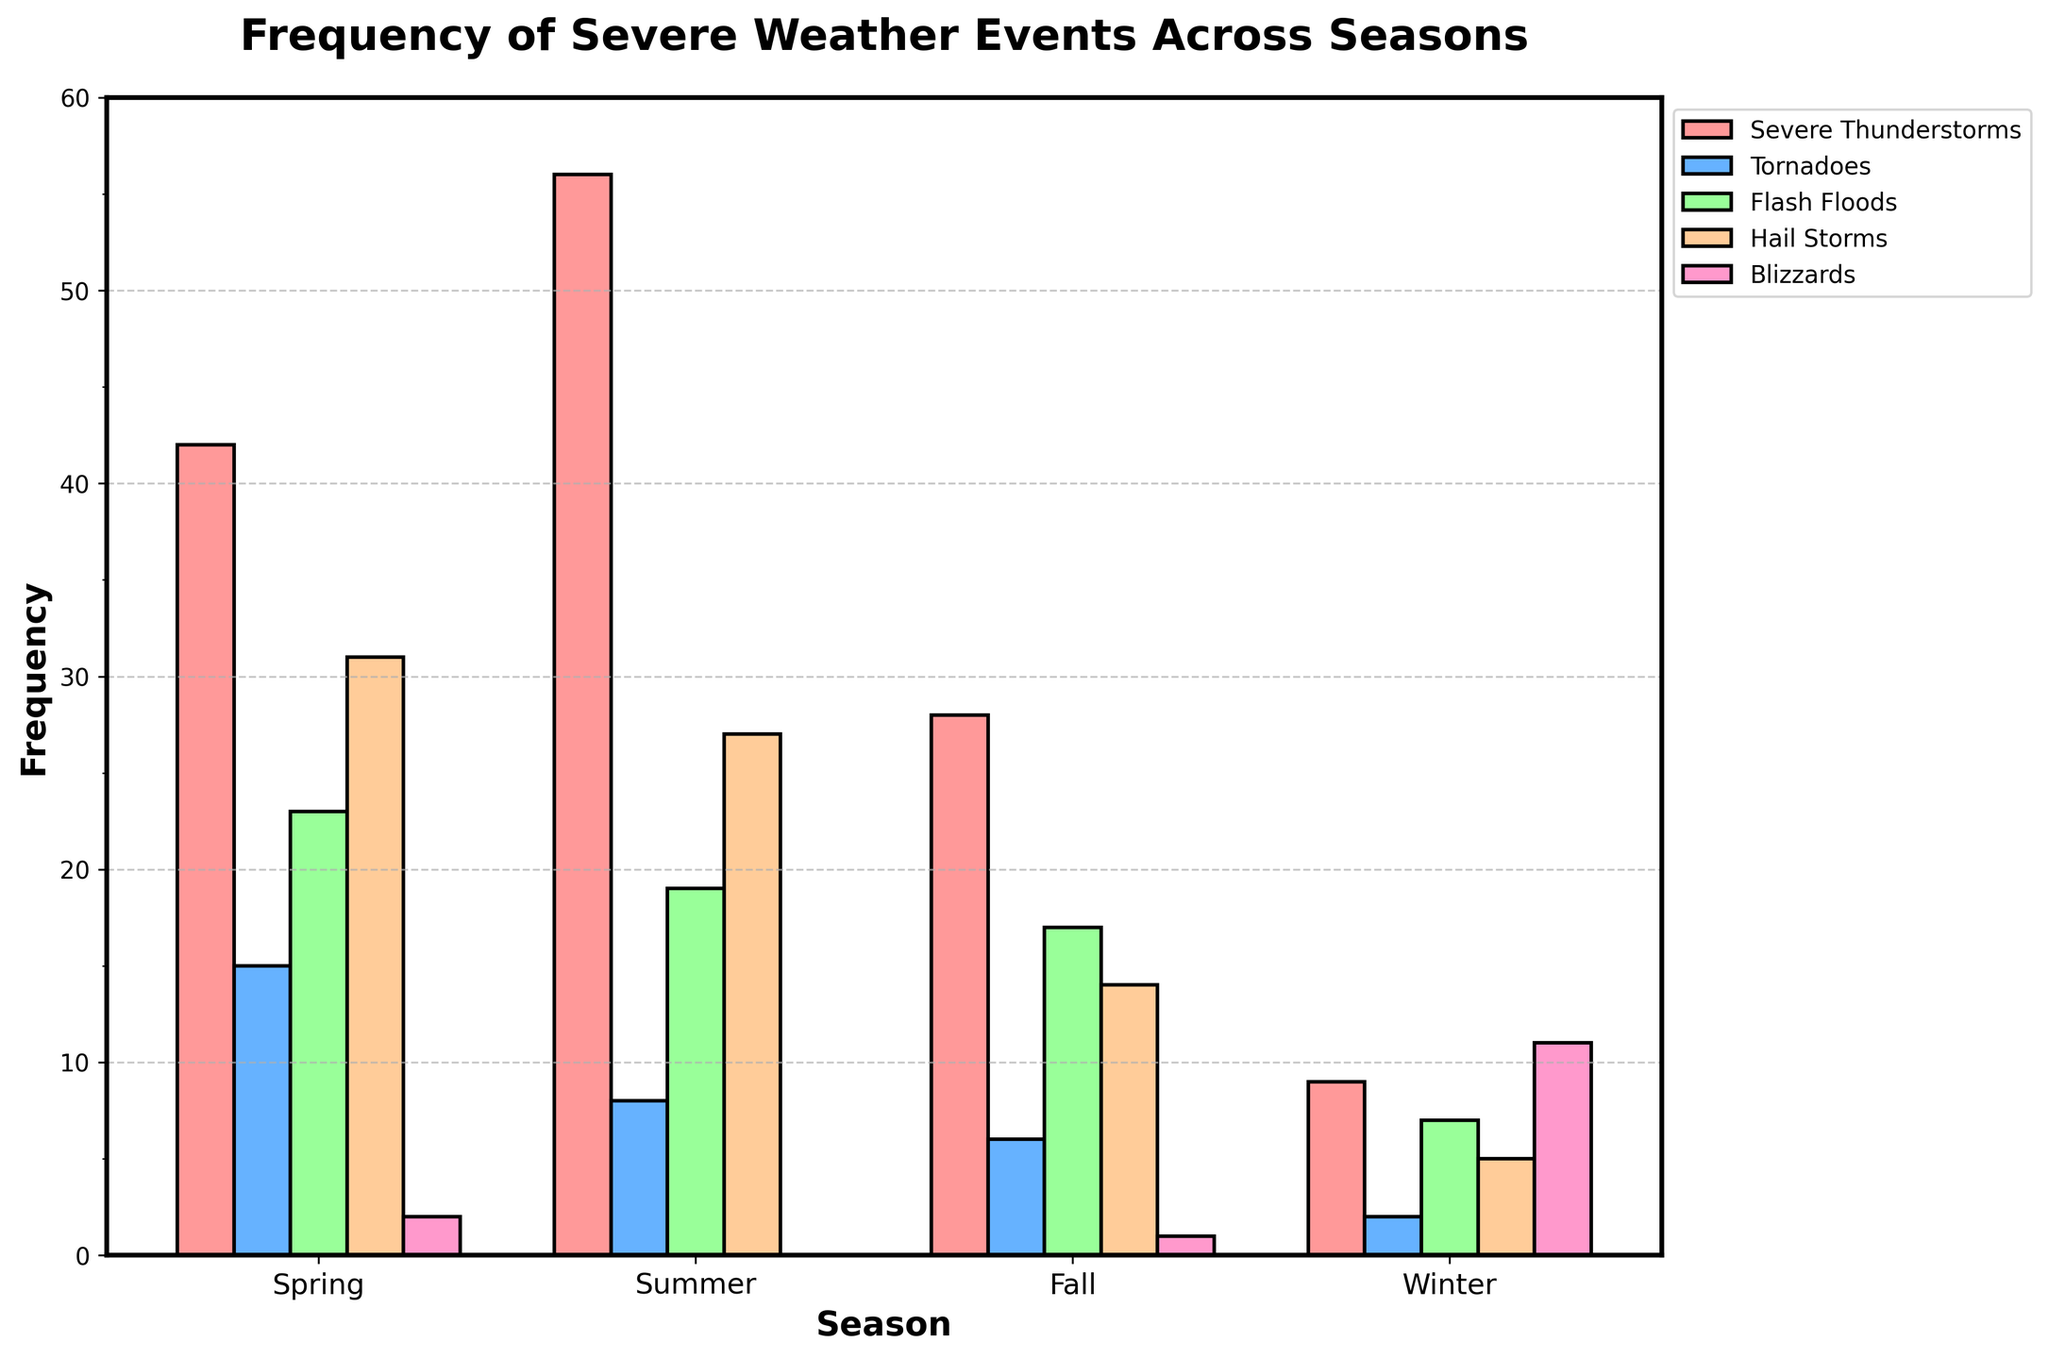Which season has the highest frequency of Severe Thunderstorms? Look at the bar heights in the Severe Thunderstorms category across all seasons and find the tallest one. Summer has the highest bar for Severe Thunderstorms.
Answer: Summer How many more Tornadoes occur in Spring compared to Fall? Find the heights of the Tornado bars for both Spring and Fall and subtract the two values. Spring has 15 Tornadoes, and Fall has 6, so 15 - 6 = 9.
Answer: 9 Which season has the lowest frequency of Flash Floods? Compare the heights of the Flash Flood bars for all seasons. Winter has the shortest bar for Flash Floods.
Answer: Winter What is the combined frequency of Hail Storms in Spring and Summer? Add the heights of the Hail Storm bars for Spring and Summer. Spring has 31 Hail Storms, and Summer has 27, so 31 + 27 = 58.
Answer: 58 How does the frequency of Blizzards in Winter compare to that in Fall? Compare the heights of the Blizzard bars in Winter and Fall. Winter's Blizzard bar is significantly taller than Fall's. Winter = 11, Fall = 1, so Winter has 10 more Blizzards.
Answer: Winter What is the average frequency of severe weather events in Winter? Sum the heights of all bars for Winter and divide by the number of events (5). Winter: 9 (Thunderstorms) + 2 (Tornadoes) + 7 (Floods) + 5 (Hail) + 11 (Blizzards) = 34. Average = 34 / 5 = 6.8.
Answer: 6.8 Which season experiences the least Hail Storms? Compare the heights of the Hail Storm bars for all seasons. Winter has the shortest bar for Hail Storms.
Answer: Winter What is the difference in the frequency of Flash Floods between Summer and Winter? Find the heights of the Flash Flood bars for Summer and Winter and subtract Winter's value from Summer's. Summer = 19, Winter = 7, so 19 - 7 = 12.
Answer: 12 Which severe weather event is most frequent in Fall? Compare the heights of all bars representing different severe weather events for Fall. The Severe Thunderstorms bar is the tallest.
Answer: Severe Thunderstorms What is the total number of Tornadoes across all seasons? Sum the heights of the Tornado bars for every season. Spring = 15, Summer = 8, Fall = 6, Winter = 2, so 15 + 8 + 6 + 2 = 31.
Answer: 31 